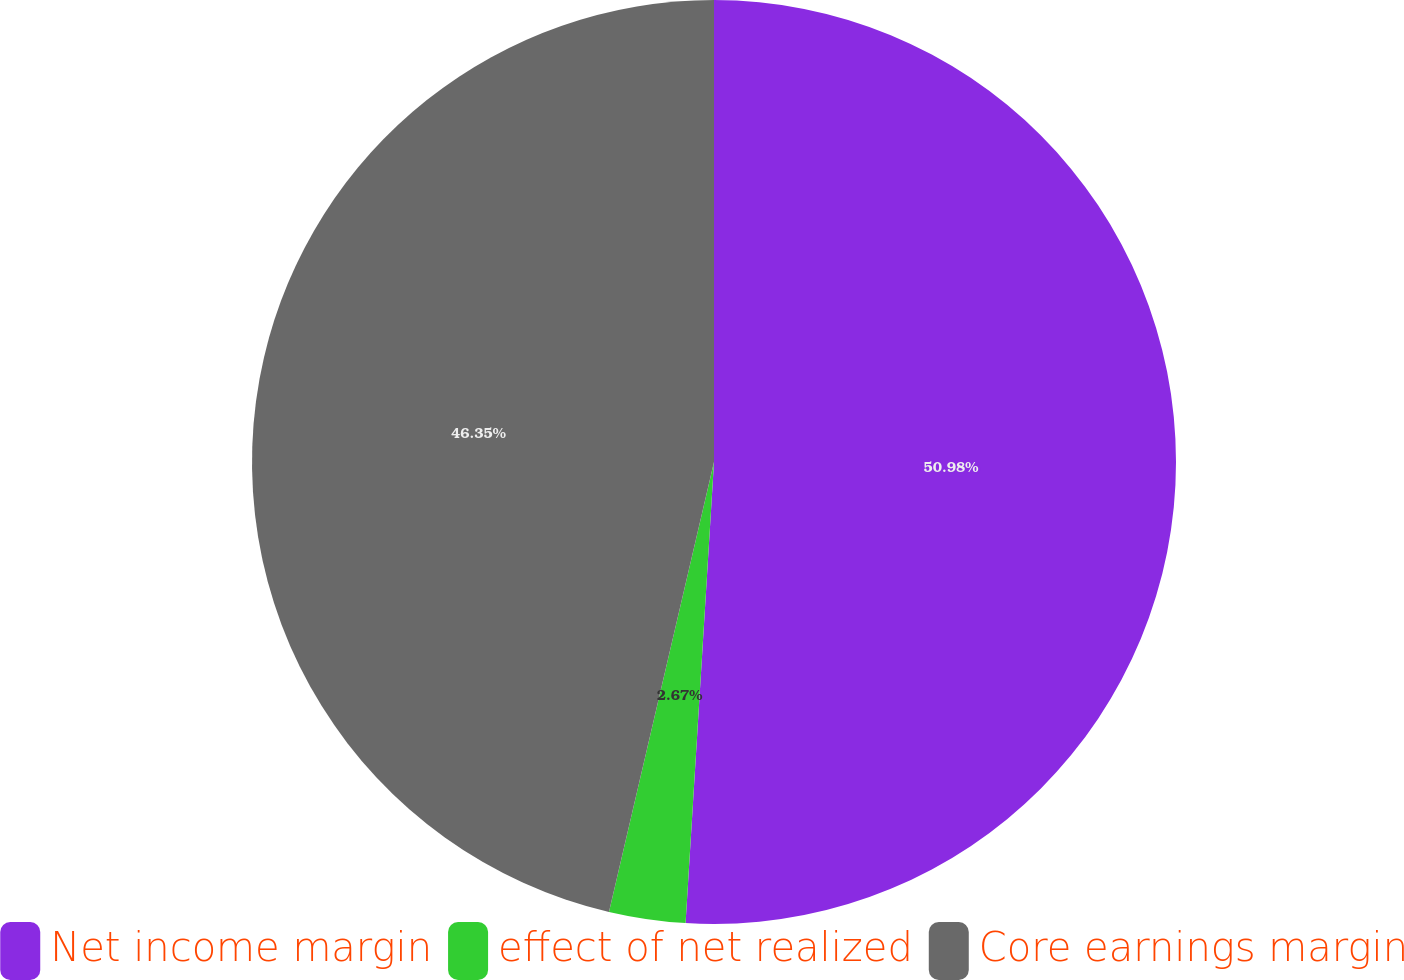Convert chart. <chart><loc_0><loc_0><loc_500><loc_500><pie_chart><fcel>Net income margin<fcel>effect of net realized<fcel>Core earnings margin<nl><fcel>50.98%<fcel>2.67%<fcel>46.35%<nl></chart> 